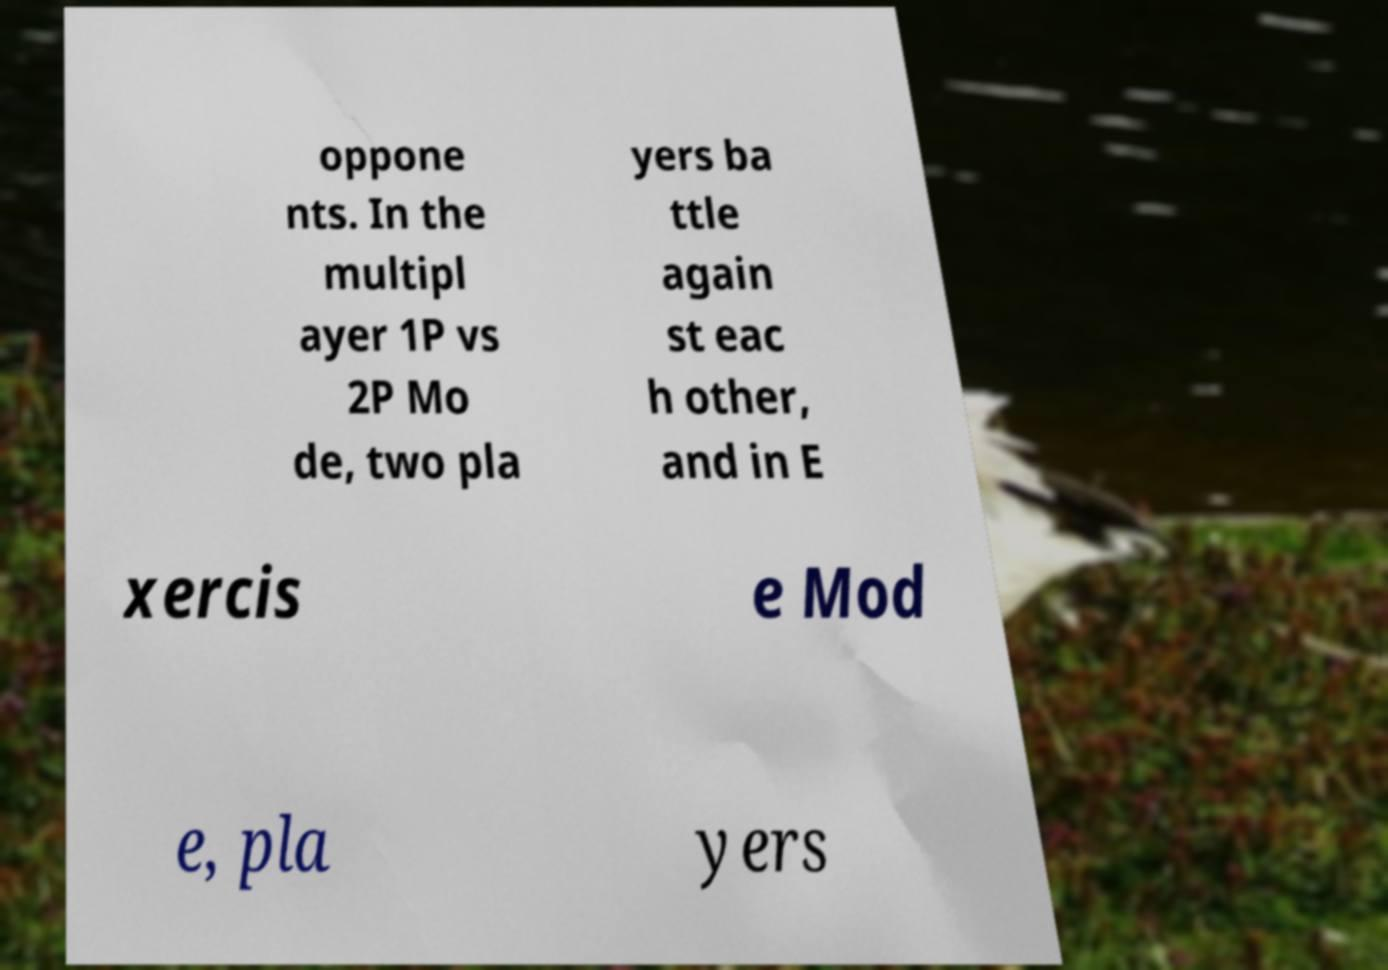Please read and relay the text visible in this image. What does it say? oppone nts. In the multipl ayer 1P vs 2P Mo de, two pla yers ba ttle again st eac h other, and in E xercis e Mod e, pla yers 